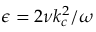Convert formula to latex. <formula><loc_0><loc_0><loc_500><loc_500>\epsilon = 2 \nu k _ { c } ^ { 2 } / \omega</formula> 